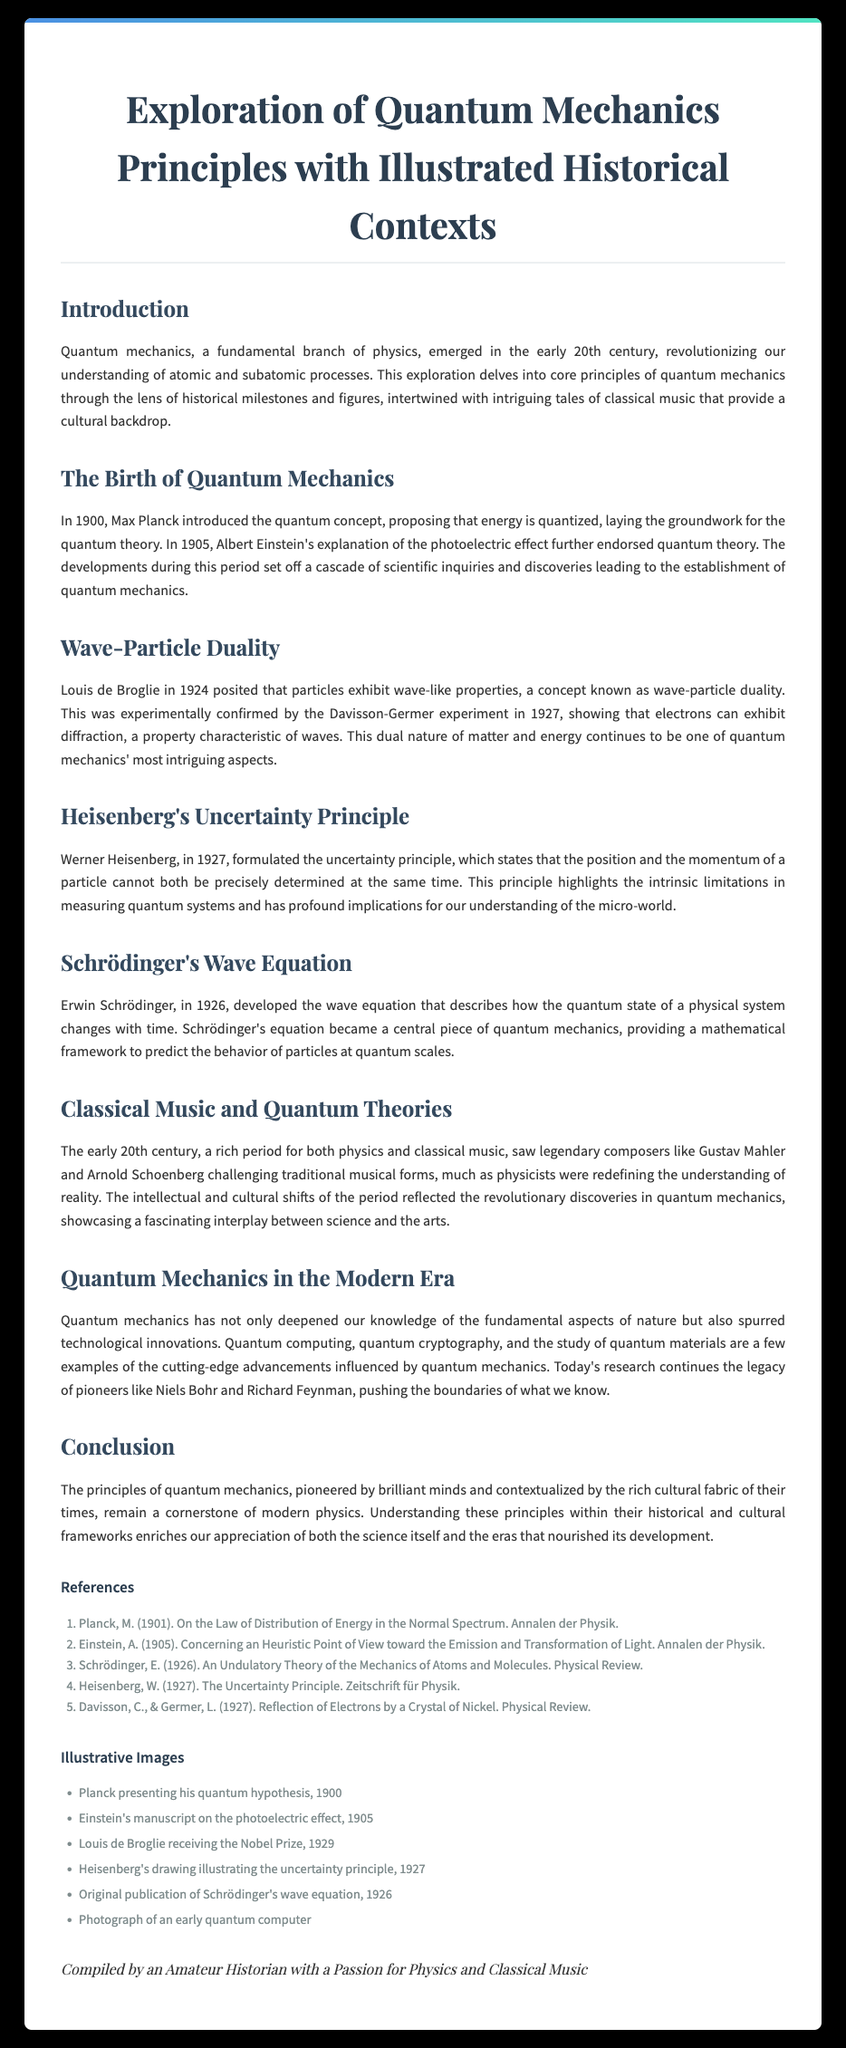What year did Max Planck introduce the quantum concept? The document states that Max Planck introduced the quantum concept in 1900.
Answer: 1900 Who formulated the uncertainty principle? According to the document, the uncertainty principle was formulated by Werner Heisenberg.
Answer: Werner Heisenberg What is the title of the document? The title of the document is displayed prominently at the top and is "Exploration of Quantum Mechanics Principles with Illustrated Historical Contexts".
Answer: Exploration of Quantum Mechanics Principles with Illustrated Historical Contexts In what year did Louis de Broglie propose wave-particle duality? The document mentions that Louis de Broglie posited wave-particle duality in 1924.
Answer: 1924 What are two examples of technological innovations influenced by quantum mechanics? The document lists quantum computing and quantum cryptography as examples of technological innovations influenced by quantum mechanics.
Answer: Quantum computing, quantum cryptography What composer is mentioned in connection with the early 20th century cultural context? The document refers to Gustav Mahler among legendary composers in the early 20th century.
Answer: Gustav Mahler What does Schrödinger's wave equation describe? The wave equation developed by Schrödinger describes how the quantum state of a physical system changes with time.
Answer: Changes with time Which experiment confirmed wave-particle duality? The document states that the Davisson-Germer experiment in 1927 confirmed wave-particle duality.
Answer: Davisson-Germer experiment What year was the original publication of Schrödinger's wave equation? According to the document, Schrödinger's wave equation was published in 1926.
Answer: 1926 